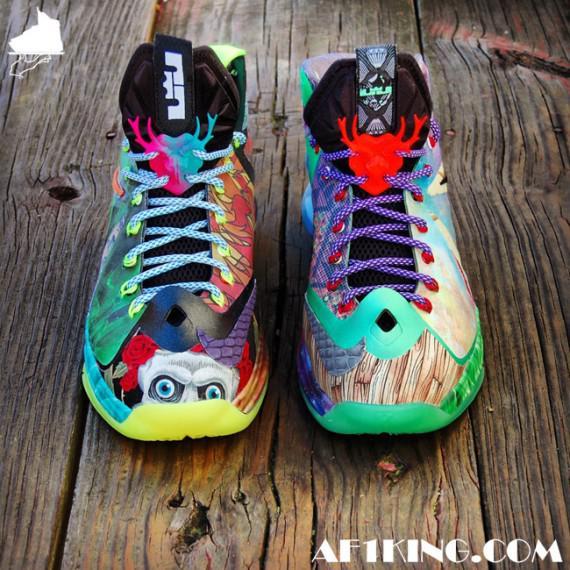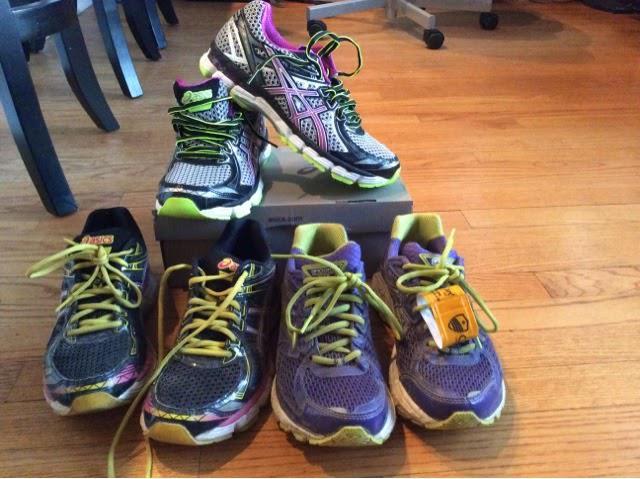The first image is the image on the left, the second image is the image on the right. Evaluate the accuracy of this statement regarding the images: "No more than three sneakers are visible in the left image.". Is it true? Answer yes or no. Yes. The first image is the image on the left, the second image is the image on the right. Considering the images on both sides, is "One of the images features no more than three shoes." valid? Answer yes or no. Yes. 